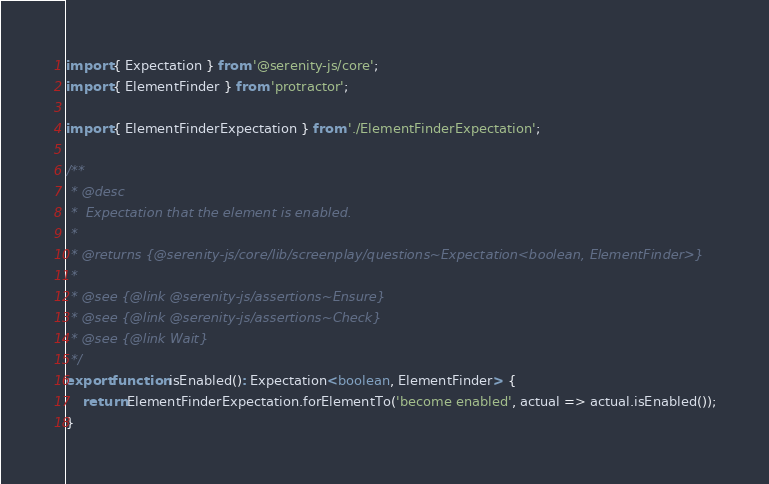Convert code to text. <code><loc_0><loc_0><loc_500><loc_500><_TypeScript_>import { Expectation } from '@serenity-js/core';
import { ElementFinder } from 'protractor';

import { ElementFinderExpectation } from './ElementFinderExpectation';

/**
 * @desc
 *  Expectation that the element is enabled.
 *
 * @returns {@serenity-js/core/lib/screenplay/questions~Expectation<boolean, ElementFinder>}
 *
 * @see {@link @serenity-js/assertions~Ensure}
 * @see {@link @serenity-js/assertions~Check}
 * @see {@link Wait}
 */
export function isEnabled(): Expectation<boolean, ElementFinder> {
    return ElementFinderExpectation.forElementTo('become enabled', actual => actual.isEnabled());
}
</code> 